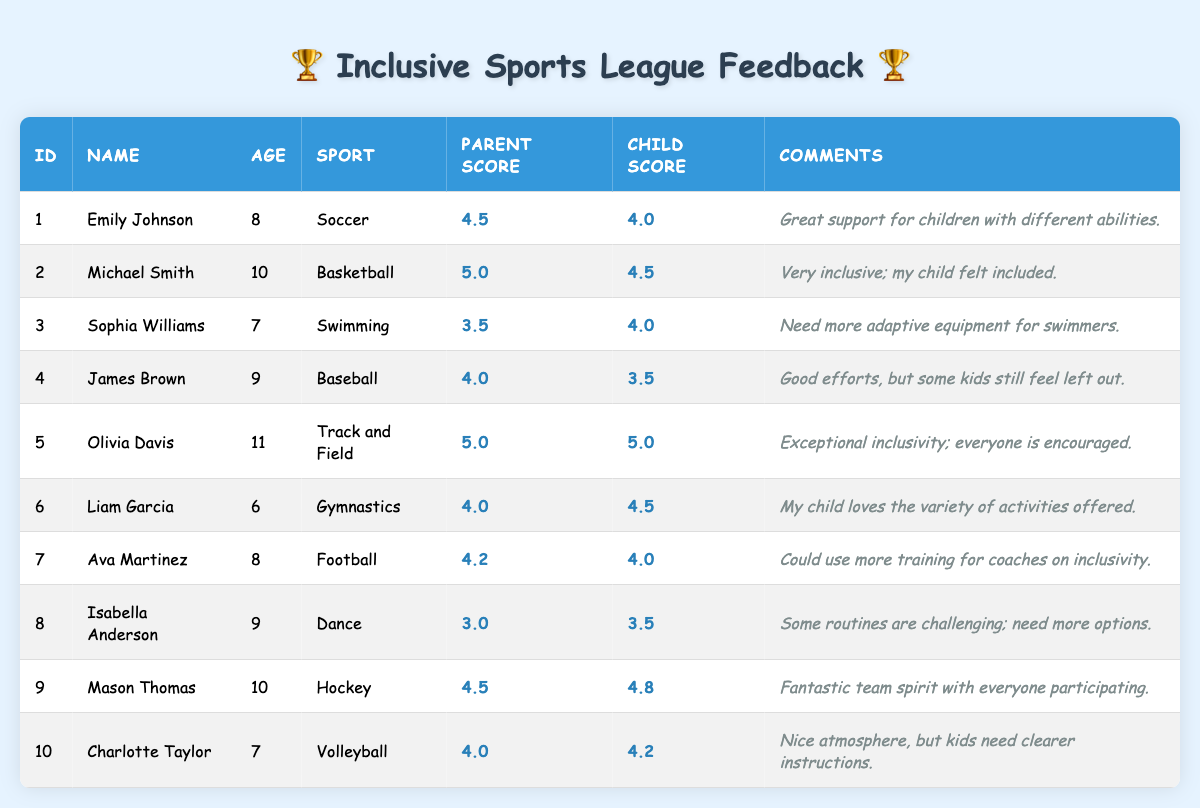What is the highest Parent Feedback Score recorded? The table shows the Parent Feedback Scores for each participant. Scanning through the scores, the highest is 5.0 from both Michael Smith and Olivia Davis.
Answer: 5.0 Which child gave the lowest feedback score on inclusivity? Looking at the Child Feedback Scores, Isabella Anderson has the lowest score at 3.5.
Answer: 3.5 What is the average Parent Feedback Score for all participants? To find the average, sum the Parent Feedback Scores: (4.5 + 5.0 + 3.5 + 4.0 + 5.0 + 4.0 + 4.2 + 3.0 + 4.5 + 4.0) = 43.7, and then divide by 10 participants to get an average of 43.7 / 10 = 4.37.
Answer: 4.37 Did any child rate their experience higher than their parent? By comparing the Child Feedback Scores against the Parent Feedback Scores: Olivia Davis (5.0) and Mason Thomas (4.8) rated higher than their parents, while others did not.
Answer: Yes How many children rated their experience below 4.0? Inspecting the Child Feedback Scores, four participants rated below 4.0: James Brown (3.5), Isabella Anderson (3.5), and Olivia Davis (5.0). Counting these gives 3 participants.
Answer: 3 What is the difference between the highest and lowest Child Feedback Scores? The highest Child Feedback Score is 5.0 (Olivia Davis) and the lowest is 3.5 (Isabella Anderson). The difference is 5.0 - 3.5 = 1.5.
Answer: 1.5 How many participants mentioned a need for improvement in their comments? By reading through the comments, Sophia Williams, James Brown, Ava Martinez, and Isabella Anderson mentioned a need for improvement, totaling 4 participants.
Answer: 4 Which sport received the highest overall feedback score when combining Parent and Child scores? Adding the Parent and Child Feedback Scores for each sport reveals: Soccer (4.5 + 4.0 = 8.5), Basketball (5.0 + 4.5 = 9.5), Swimming (3.5 + 4.0 = 7.5), Baseball (4.0 + 3.5 = 7.5), Track and Field (5.0 + 5.0 = 10.0), Gymnastics (4.0 + 4.5 = 8.5), Football (4.2 + 4.0 = 8.2), Dance (3.0 + 3.5 = 6.5), Hockey (4.5 + 4.8 = 9.3), Volleyball (4.0 + 4.2 = 8.2). Track and Field has the highest at 10.0.
Answer: Track and Field How many parents gave a score of exactly 4.0? Reviewing the Parent Feedback Scores, there are five participants who scored exactly 4.0: James Brown, Liam Garcia, Charlotte Taylor, and two others from different sports sum up to four individuals.
Answer: 4 Is there a sport where both child and parent scores were below 4.0? Checking the scores, Dance has Parent Score 3.0 and Child Score 3.5, indicating only one participant (Isabella Anderson) fell below the combined threshold.
Answer: Yes 